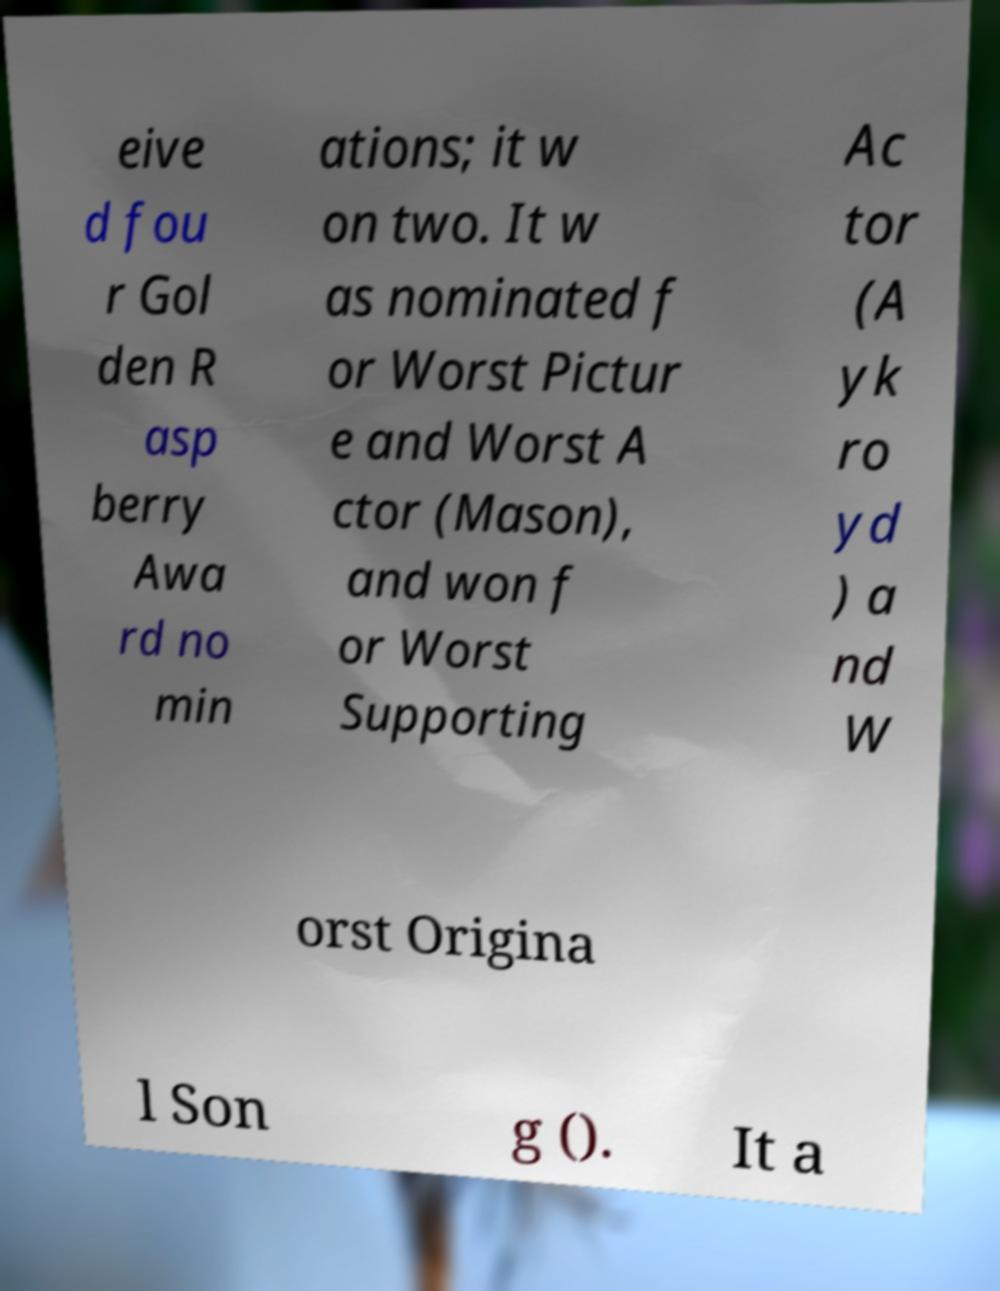I need the written content from this picture converted into text. Can you do that? eive d fou r Gol den R asp berry Awa rd no min ations; it w on two. It w as nominated f or Worst Pictur e and Worst A ctor (Mason), and won f or Worst Supporting Ac tor (A yk ro yd ) a nd W orst Origina l Son g (). It a 